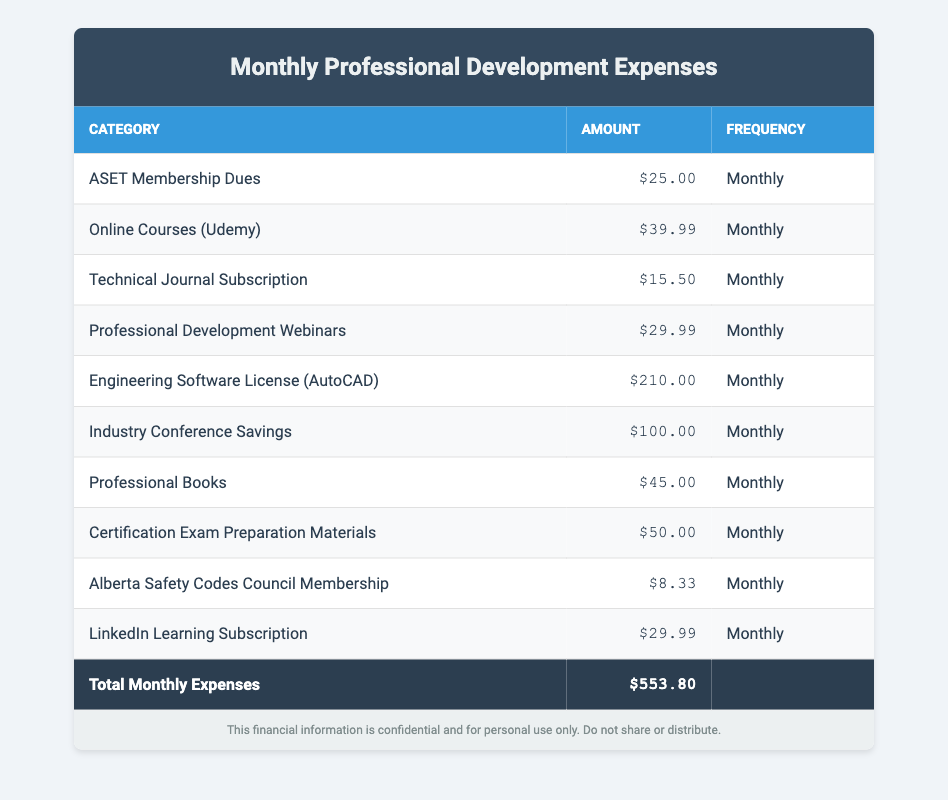What is the total amount of monthly expenses for professional development? The total amount of monthly expenses is provided in the last row of the table where it states "Total Monthly Expenses," which shows an amount of $553.80.
Answer: $553.80 How much do I spend on online courses each month? The specific amount for online courses (Udemy) is listed under the "Online Courses (Udemy)" row, which states the amount is $39.99.
Answer: $39.99 Is the amount spent on the Engineering Software License (AutoCAD) higher than the total spent on ASET Membership Dues and Technical Journal Subscription combined? The Engineering Software License amounts to $210.00. The combined total of ASET Membership Dues ($25.00) and Technical Journal Subscription ($15.50) is $40.50, which is less than $210.00.
Answer: Yes What is the average monthly expense for the categories listed in the table? To calculate the average monthly expense, we sum all the amounts: ($25.00 + $39.99 + $15.50 + $29.99 + $210.00 + $100.00 + $45.00 + $50.00 + $8.33 + $29.99) = $553.80. Then, dividing by the number of categories (10), gives $553.80 / 10 = $55.38.
Answer: $55.38 Which category has the highest expense? We can find the highest expense by checking all the amounts in each row. The "Engineering Software License (AutoCAD)" has the highest expense at $210.00.
Answer: Engineering Software License (AutoCAD) Is the total of Industry Conference Savings and Professional Books greater than the total of LinkedIn Learning Subscription and ASET Membership Dues? Industry Conference Savings is $100.00 and Professional Books is $45.00, totaling $145.00. LinkedIn Learning Subscription is $29.99 and ASET Membership Dues is $25.00, totaling $54.99. Since $145.00 is greater than $54.99, the statement is true.
Answer: Yes What are the total expenses for certification-related costs (Certification Exam Preparation Materials and ASET Membership Dues)? The Certification Exam Preparation Materials total is $50.00 and ASET Membership Dues is $25.00. Adding these ($50.00 + $25.00) gives the total certification-related costs of $75.00.
Answer: $75.00 How much do I spend on Professional Development Webinars compared to the Technical Journal Subscription? The amount spent on Professional Development Webinars is $29.99, while the Technical Journal Subscription costs $15.50. The expense on Webinars is greater than that of the Journal.
Answer: Professional Development Webinars is higher 